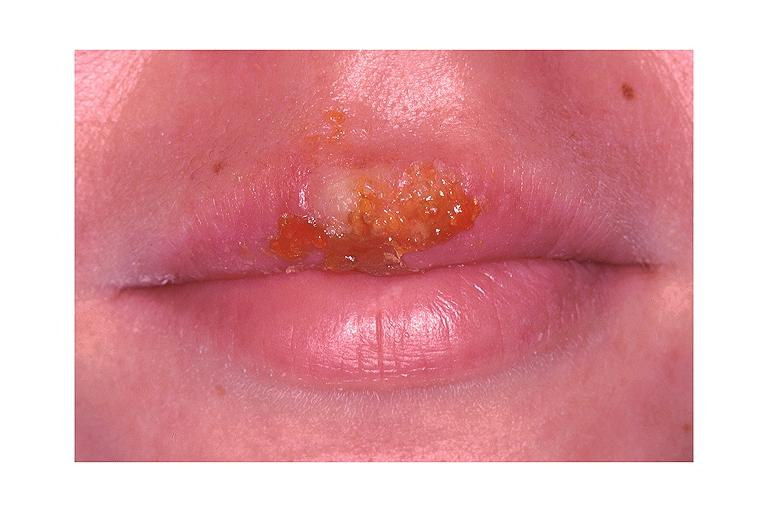does this image show recurrent herpes labialis?
Answer the question using a single word or phrase. Yes 